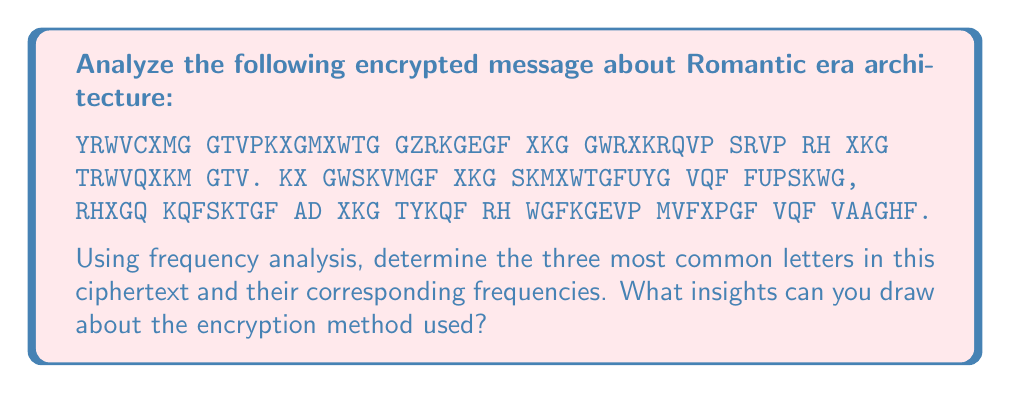Show me your answer to this math problem. To solve this problem, we need to follow these steps:

1. Count the frequency of each letter in the ciphertext.
2. Calculate the percentage frequency for each letter.
3. Identify the three most common letters.
4. Compare the results with standard English letter frequencies.
5. Draw conclusions about the encryption method.

Step 1: Counting letter frequencies

We can create a table to count the occurrences of each letter:

A: 4, C: 2, D: 2, E: 7, F: 7, G: 13, H: 2, K: 8, M: 8, N: 1, P: 3, Q: 5, R: 7, S: 4, T: 8, U: 2, V: 7, W: 5, X: 10, Y: 1, Z: 1

Total letters: 107

Step 2: Calculating percentage frequencies

For each letter, we calculate the percentage:
$$ \text{Percentage} = \frac{\text{Letter count}}{\text{Total letters}} \times 100\% $$

G: $\frac{13}{107} \times 100\% \approx 12.15\%$
X: $\frac{10}{107} \times 100\% \approx 9.35\%$
K: $\frac{8}{107} \times 100\% \approx 7.48\%$
M: $\frac{8}{107} \times 100\% \approx 7.48\%$
T: $\frac{8}{107} \times 100\% \approx 7.48\%$

Step 3: Identifying the three most common letters

The three most common letters are:
1. G (12.15%)
2. X (9.35%)
3. K, M, T (tied at 7.48%)

Step 4: Comparing with standard English frequencies

In standard English, the most common letters are E (12.7%), T (9.1%), and A (8.2%).

Step 5: Drawing conclusions

The frequency distribution suggests a simple substitution cipher:
- G likely represents E
- X might represent T
- K, M, or T could represent A

The consistent letter substitution and similar frequency distribution to standard English indicate a monoalphabetic substitution cipher, possibly a Caesar cipher or a more complex key-based substitution.
Answer: G (12.15%), X (9.35%), K/M/T (7.48%); likely monoalphabetic substitution cipher 